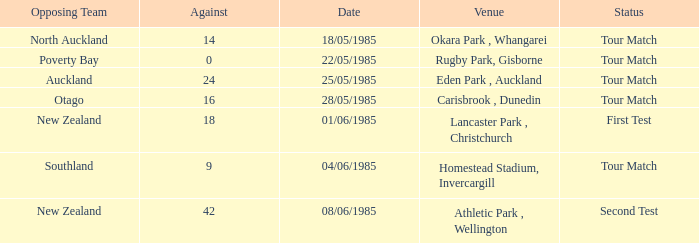Which venue had an against score smaller than 18 when the opposing team was North Auckland? Okara Park , Whangarei. 